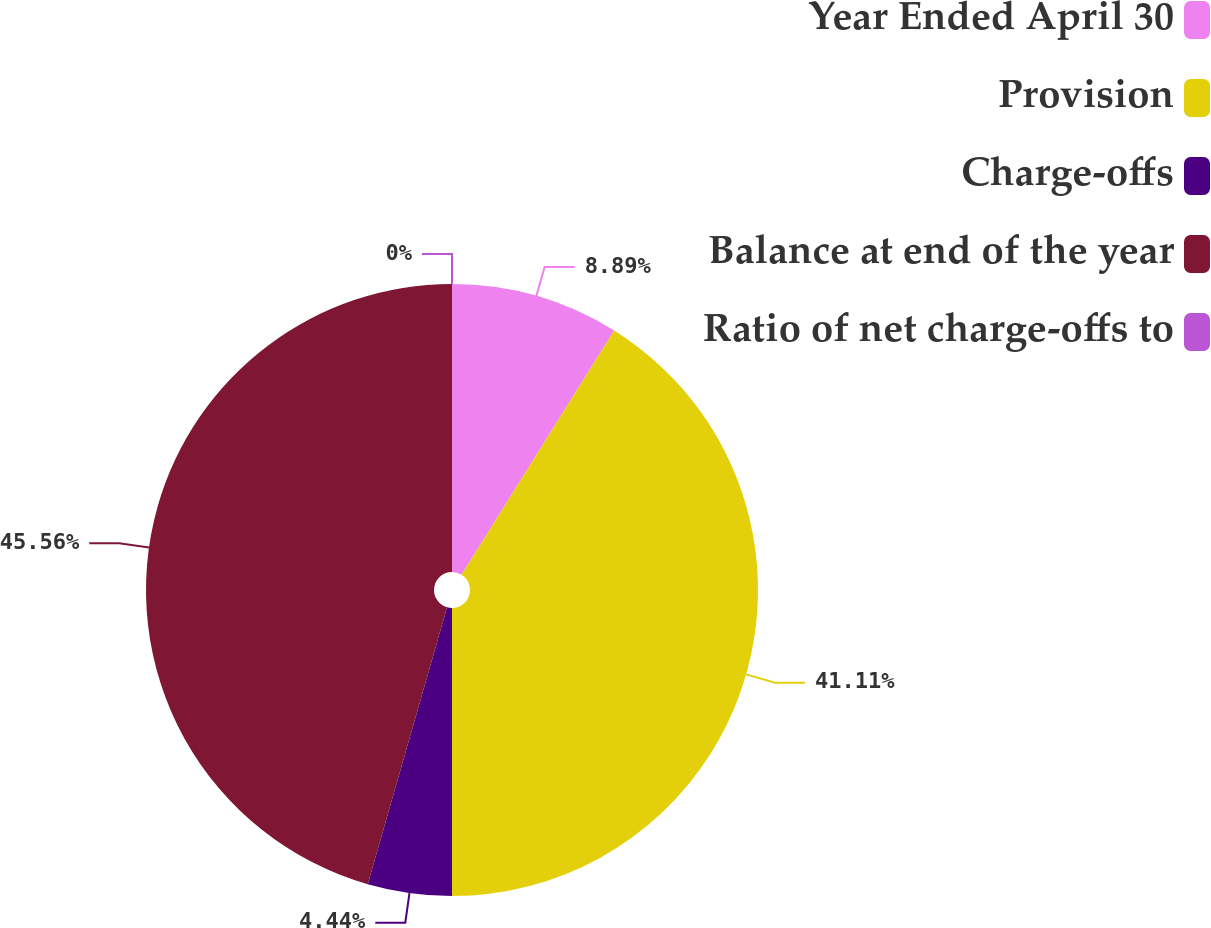<chart> <loc_0><loc_0><loc_500><loc_500><pie_chart><fcel>Year Ended April 30<fcel>Provision<fcel>Charge-offs<fcel>Balance at end of the year<fcel>Ratio of net charge-offs to<nl><fcel>8.89%<fcel>41.11%<fcel>4.44%<fcel>45.56%<fcel>0.0%<nl></chart> 